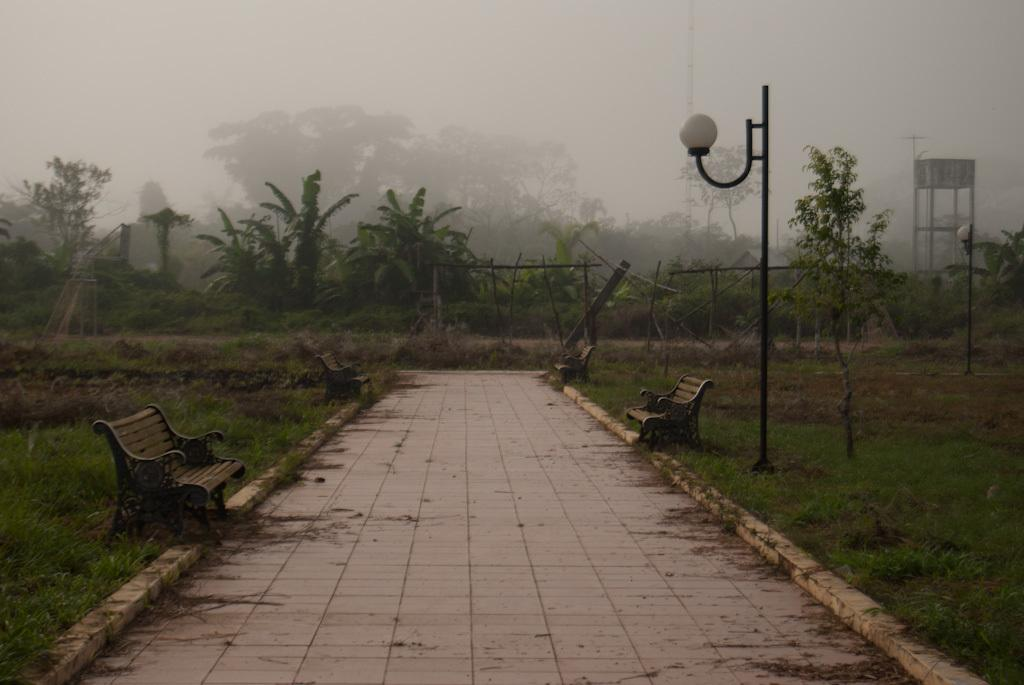What type of surface can be seen in the image? There is a pathway in the image. Are there any seating options visible along the pathway? Yes, there are benches beside the pathway. What type of vegetation is present in the image? There is grass visible in the image. What type of structure can be seen near the pathway? A street pole is present in the image. What type of natural barrier is present in the image? There is a group of trees in the image. What type of enclosure is present in the image? There is a fence in the image. What is the condition of the sky in the image? The sky is visible in the image and appears cloudy. What type of mint can be seen growing near the fence in the image? There is no mint present in the image; only grass is visible. 